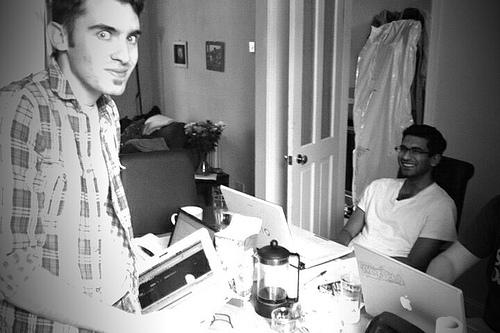How does the seated man think the standing man is acting? funny 